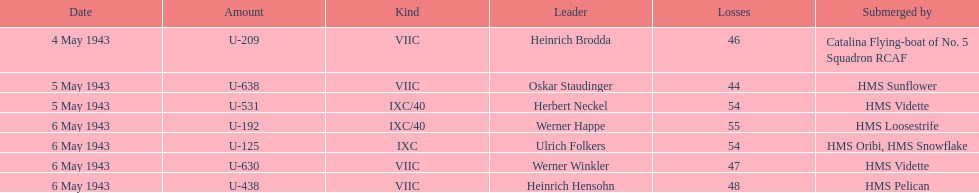What was the number of casualties on may 4 1943? 46. 